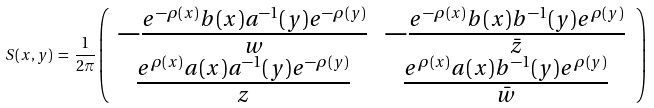<formula> <loc_0><loc_0><loc_500><loc_500>S ( x , y ) \, = \, { \frac { 1 } { 2 \pi } } \left ( \begin{array} { c c } - \frac { e ^ { - \rho ( x ) } b ( x ) a ^ { - 1 } ( y ) e ^ { - \rho ( y ) } } { w } & - \frac { e ^ { - \rho ( x ) } b ( x ) b ^ { - 1 } ( y ) e ^ { \rho ( y ) } } { \bar { z } } \\ \frac { e ^ { \rho ( x ) } a ( x ) a ^ { - 1 } ( y ) e ^ { - \rho ( y ) } } { z } & \frac { e ^ { \rho ( x ) } a ( x ) b ^ { - 1 } ( y ) e ^ { \rho ( y ) } } { \bar { w } } \end{array} \, \right ) \,</formula> 